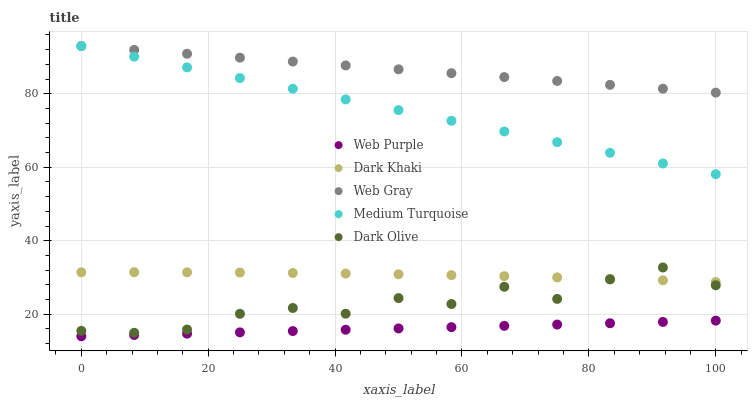Does Web Purple have the minimum area under the curve?
Answer yes or no. Yes. Does Web Gray have the maximum area under the curve?
Answer yes or no. Yes. Does Web Gray have the minimum area under the curve?
Answer yes or no. No. Does Web Purple have the maximum area under the curve?
Answer yes or no. No. Is Web Purple the smoothest?
Answer yes or no. Yes. Is Dark Olive the roughest?
Answer yes or no. Yes. Is Web Gray the smoothest?
Answer yes or no. No. Is Web Gray the roughest?
Answer yes or no. No. Does Web Purple have the lowest value?
Answer yes or no. Yes. Does Web Gray have the lowest value?
Answer yes or no. No. Does Medium Turquoise have the highest value?
Answer yes or no. Yes. Does Web Purple have the highest value?
Answer yes or no. No. Is Web Purple less than Web Gray?
Answer yes or no. Yes. Is Dark Khaki greater than Web Purple?
Answer yes or no. Yes. Does Dark Olive intersect Dark Khaki?
Answer yes or no. Yes. Is Dark Olive less than Dark Khaki?
Answer yes or no. No. Is Dark Olive greater than Dark Khaki?
Answer yes or no. No. Does Web Purple intersect Web Gray?
Answer yes or no. No. 